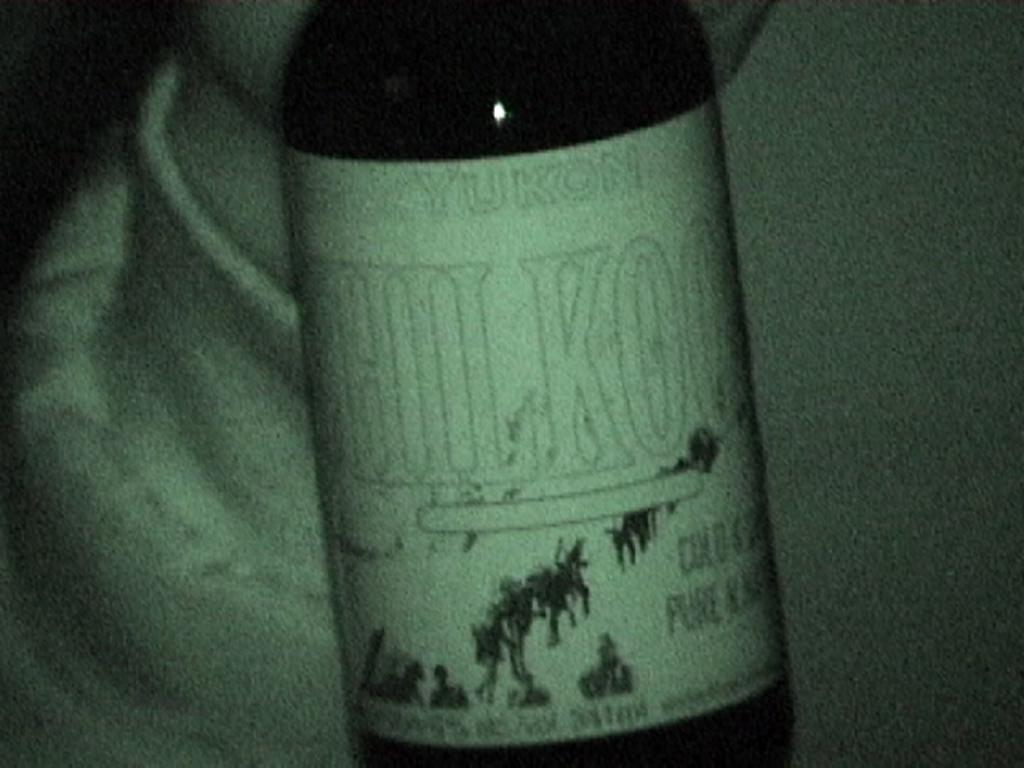What object can be seen in the image? There is a bottle in the image. What is on the bottle? The bottle has a sticker on it. What information is on the sticker? There is text and images on the sticker. What type of stone is supporting the earth in the image? There is no stone or earth present in the image; it only features a bottle with a sticker on it. 